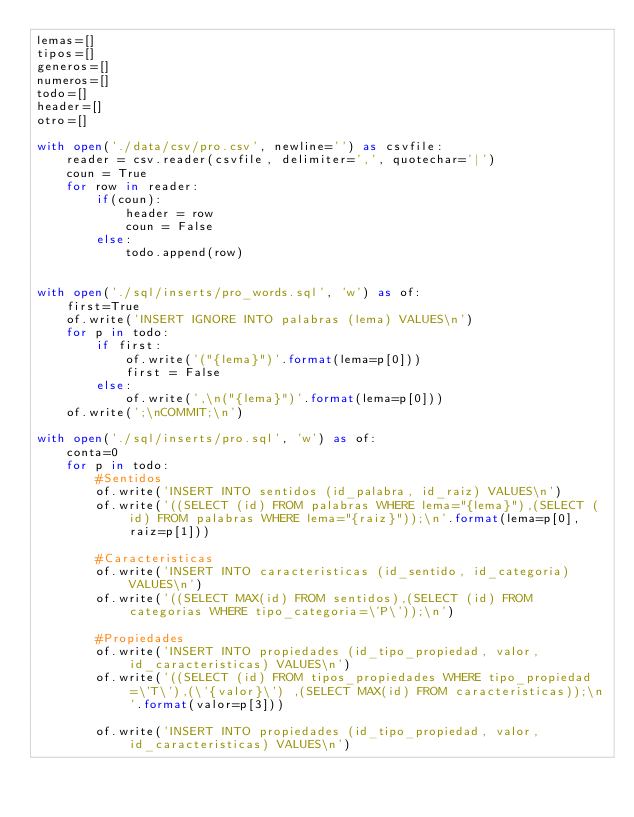Convert code to text. <code><loc_0><loc_0><loc_500><loc_500><_Python_>lemas=[]
tipos=[]
generos=[]
numeros=[]
todo=[]
header=[]
otro=[]

with open('./data/csv/pro.csv', newline='') as csvfile:
    reader = csv.reader(csvfile, delimiter=',', quotechar='|')
    coun = True
    for row in reader:
        if(coun):
            header = row
            coun = False
        else:
            todo.append(row)


with open('./sql/inserts/pro_words.sql', 'w') as of:
    first=True
    of.write('INSERT IGNORE INTO palabras (lema) VALUES\n')
    for p in todo:
        if first:
            of.write('("{lema}")'.format(lema=p[0]))
            first = False
        else:
            of.write(',\n("{lema}")'.format(lema=p[0]))
    of.write(';\nCOMMIT;\n')

with open('./sql/inserts/pro.sql', 'w') as of:
    conta=0
    for p in todo:
        #Sentidos
        of.write('INSERT INTO sentidos (id_palabra, id_raiz) VALUES\n')
        of.write('((SELECT (id) FROM palabras WHERE lema="{lema}"),(SELECT (id) FROM palabras WHERE lema="{raiz}"));\n'.format(lema=p[0],raiz=p[1]))
        
        #Caracteristicas
        of.write('INSERT INTO caracteristicas (id_sentido, id_categoria) VALUES\n')
        of.write('((SELECT MAX(id) FROM sentidos),(SELECT (id) FROM categorias WHERE tipo_categoria=\'P\'));\n')

        #Propiedades
        of.write('INSERT INTO propiedades (id_tipo_propiedad, valor, id_caracteristicas) VALUES\n')
        of.write('((SELECT (id) FROM tipos_propiedades WHERE tipo_propiedad=\'T\'),(\'{valor}\') ,(SELECT MAX(id) FROM caracteristicas));\n'.format(valor=p[3]))

        of.write('INSERT INTO propiedades (id_tipo_propiedad, valor, id_caracteristicas) VALUES\n')</code> 